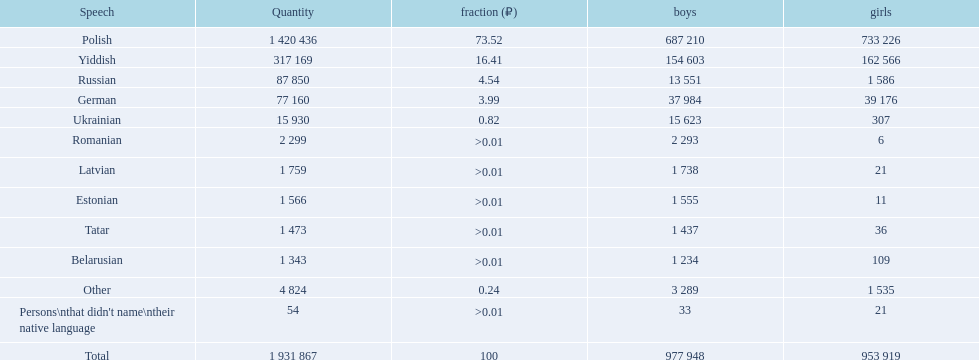What languages are spoken in the warsaw governorate? Polish, Yiddish, Russian, German, Ukrainian, Romanian, Latvian, Estonian, Tatar, Belarusian, Other, Persons\nthat didn't name\ntheir native language. What is the number for russian? 87 850. On this list what is the next lowest number? 77 160. Which language has a number of 77160 speakers? German. 